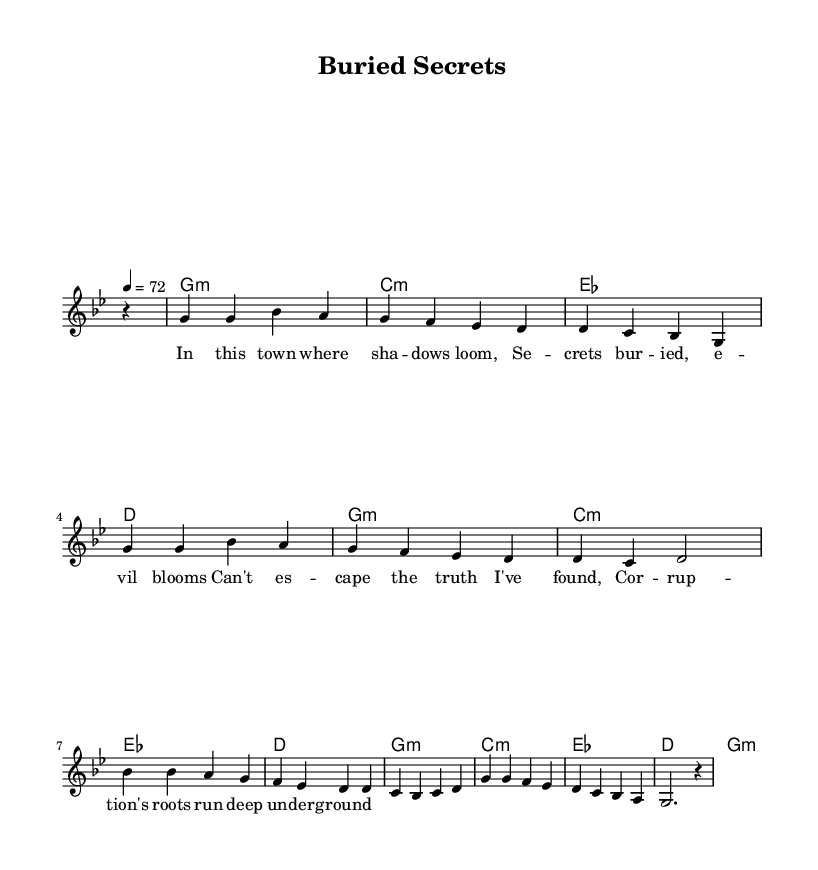What is the key signature of this music? The key signature is G minor, which has two flats (B♭ and E♭). This is determined by identifying the key indicated at the beginning of the music, right after the "global" block.
Answer: G minor What is the time signature of this music? The time signature is 4/4, indicated by the "time" command in the "global" block. This means there are four beats in each measure and the quarter note gets one beat.
Answer: 4/4 What is the tempo marking of this music? The tempo marking is 72 beats per minute, as specified by "tempo 4 = 72" in the global settings. This indicates the speed at which the song should be played.
Answer: 72 How many measures are in the melody? The melody has a total of 8 measures, as counted by the sections separated by the breaks (represented by "\break"). Each line has a measure count that adds up to 8.
Answer: 8 What is the first chord in the harmony? The first chord in the harmony is G minor, indicated by "g1:m" at the start of the harmony section. It's commonly found in the first measure of the chord progression.
Answer: G minor What thematic element is portrayed in the lyrics? The lyrics portray themes of corruption and hidden truths in a small town, indicated by phrases like "secrets buried" and "corruption's roots run deep." The text focuses on dark and gritty realities, typical in country ballads.
Answer: Corruption 